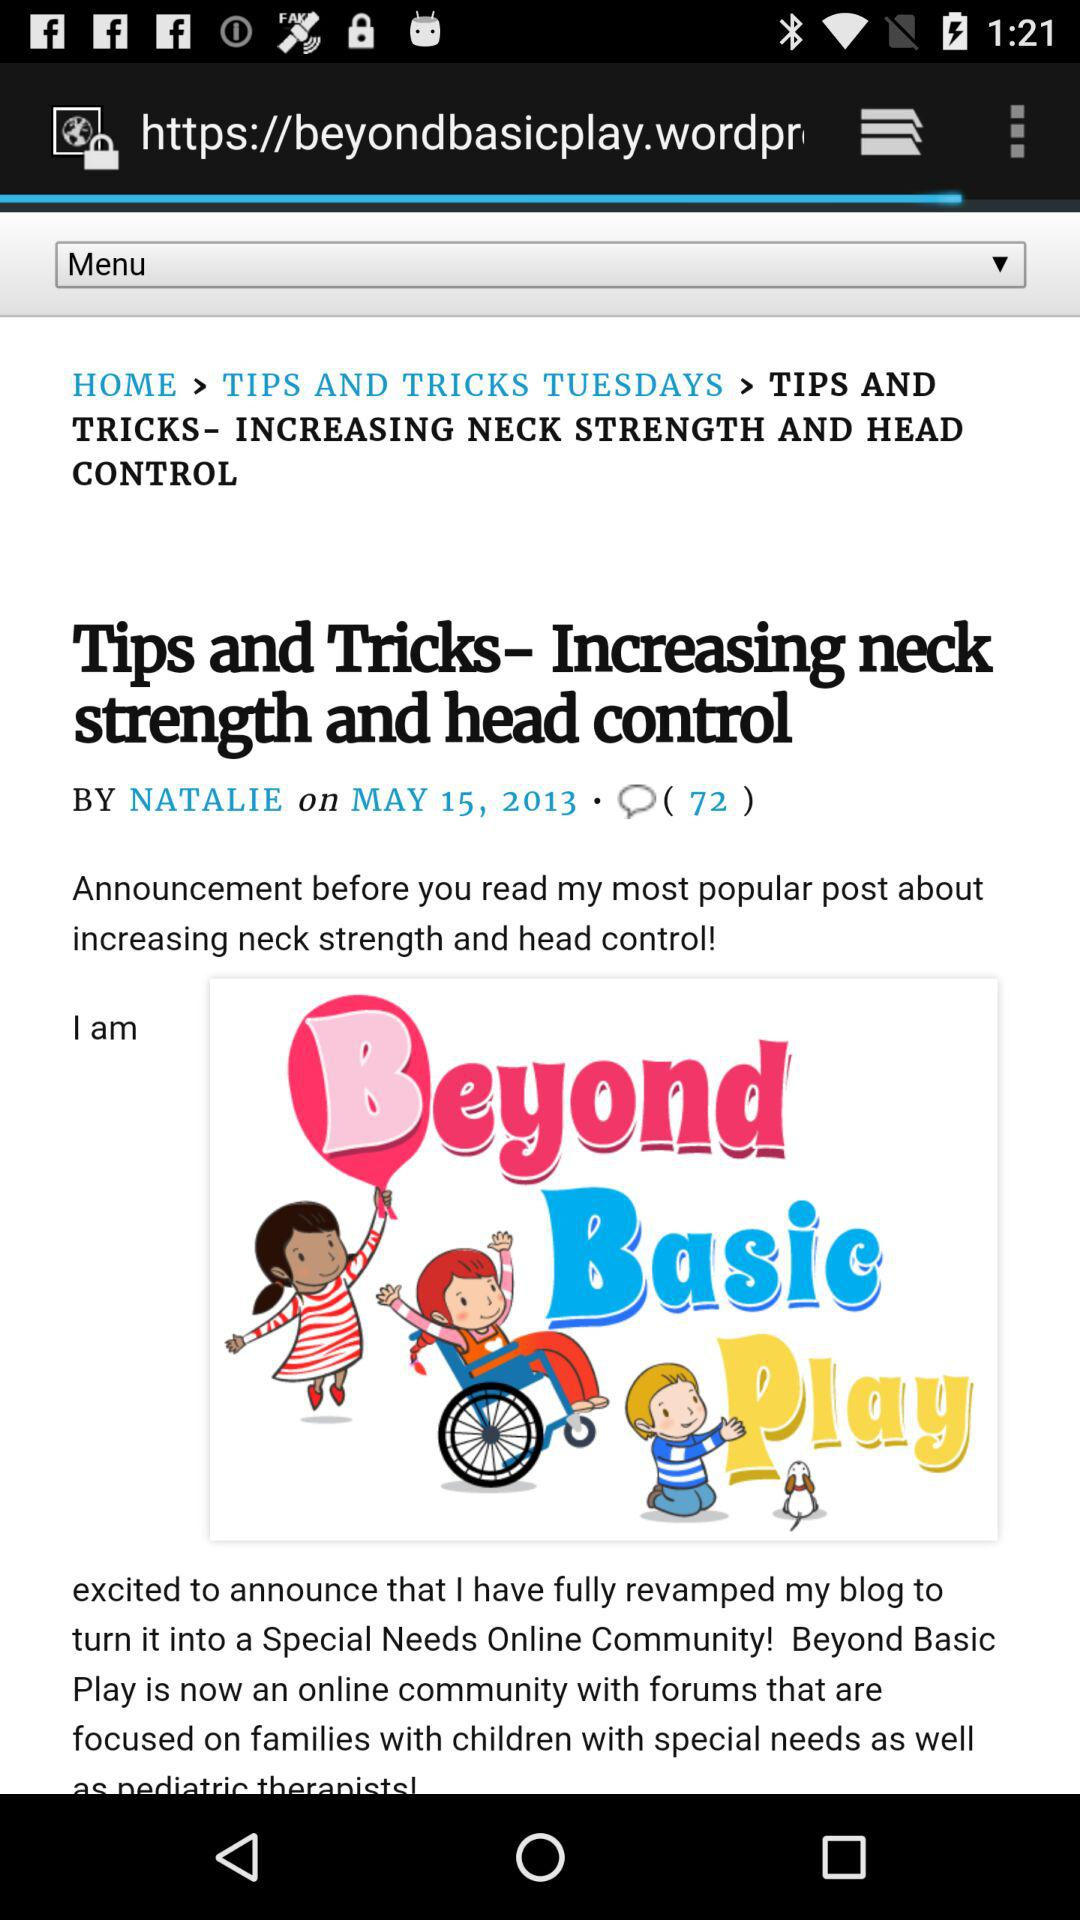How many comments are there? There are 72 comments. 